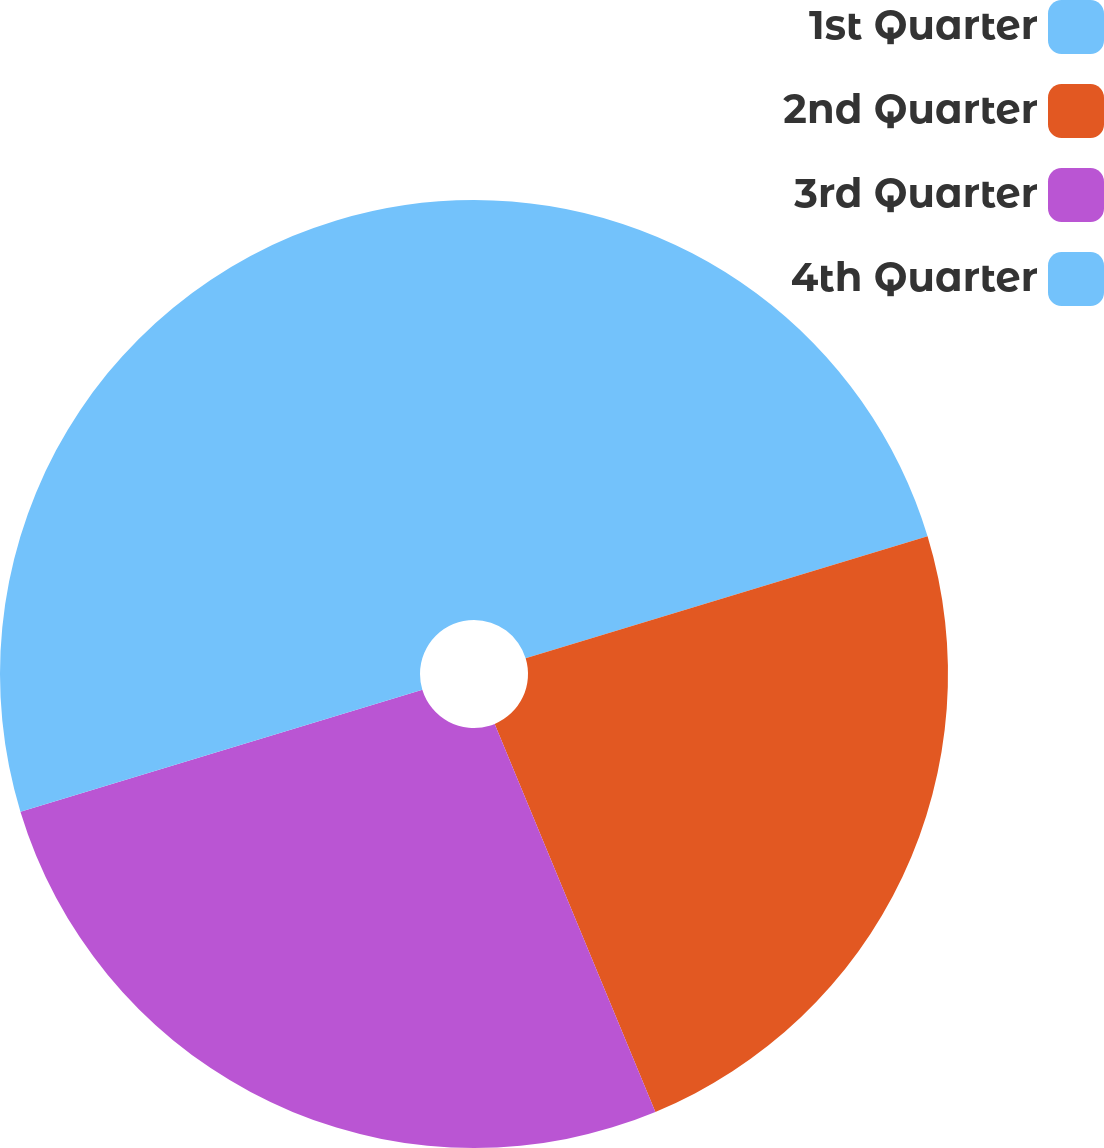<chart> <loc_0><loc_0><loc_500><loc_500><pie_chart><fcel>1st Quarter<fcel>2nd Quarter<fcel>3rd Quarter<fcel>4th Quarter<nl><fcel>20.31%<fcel>23.44%<fcel>26.56%<fcel>29.69%<nl></chart> 